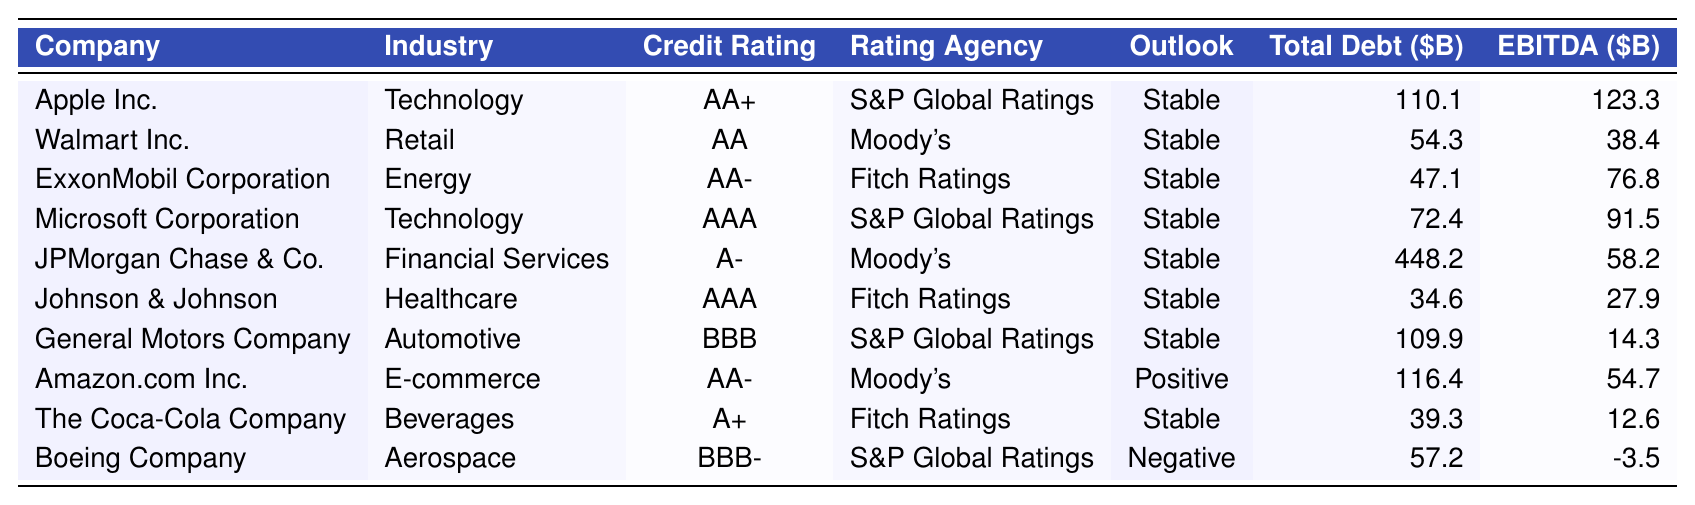What is the credit rating of Microsoft Corporation? Microsoft Corporation has a credit rating listed as AAA in the table.
Answer: AAA Which company has the highest total debt? By examining the total debt column, JPMorgan Chase & Co. has the highest total debt at 448.2 billion dollars.
Answer: JPMorgan Chase & Co What is the outlook for Amazon.com Inc.? The outlook for Amazon.com Inc. is specified as Positive in the table.
Answer: Positive Is Boeing Company rated higher than General Motors Company? Boeing Company has a rating of BBB- while General Motors Company has a rating of BBB; since BBB- is lower, Boeing is not rated higher than General Motors.
Answer: No What is the total debt for Walmart Inc. and Johnson & Johnson combined? Walmart Inc. has a total debt of 54.3 billion dollars, and Johnson & Johnson has 34.6 billion dollars. When summed (54.3 + 34.6), the result is 88.9 billion dollars.
Answer: 88.9 How many companies have a credit rating of AAA? There are two companies listed with a credit rating of AAA: Microsoft Corporation and Johnson & Johnson.
Answer: 2 What is the average EBITDA of the companies in the technology industry? The EBITDA values for the technology industry companies (Apple Inc., Microsoft Corporation) are 123.3 and 91.5 billion dollars. Summing them gives 214.8 billion dollars; averaging this over 2 companies gives 214.8 / 2 = 107.4 billion dollars.
Answer: 107.4 What company has the lowest EBITDA, and what is its value? By reviewing the EBITDA column, Boeing Company has the lowest EBITDA at -3.5 billion dollars.
Answer: Boeing Company, -3.5 Are there any companies rated A or higher in the healthcare industry? Only one healthcare company, Johnson & Johnson, is listed with a rating of AAA, which is higher than A.
Answer: Yes What is the difference in total debt between Apple Inc. and ExxonMobil Corporation? Apple Inc.'s total debt is 110.1 billion dollars, while ExxonMobil Corporation's total debt is 47.1 billion dollars. The difference is calculated as 110.1 - 47.1, which results in 63 billion dollars.
Answer: 63 